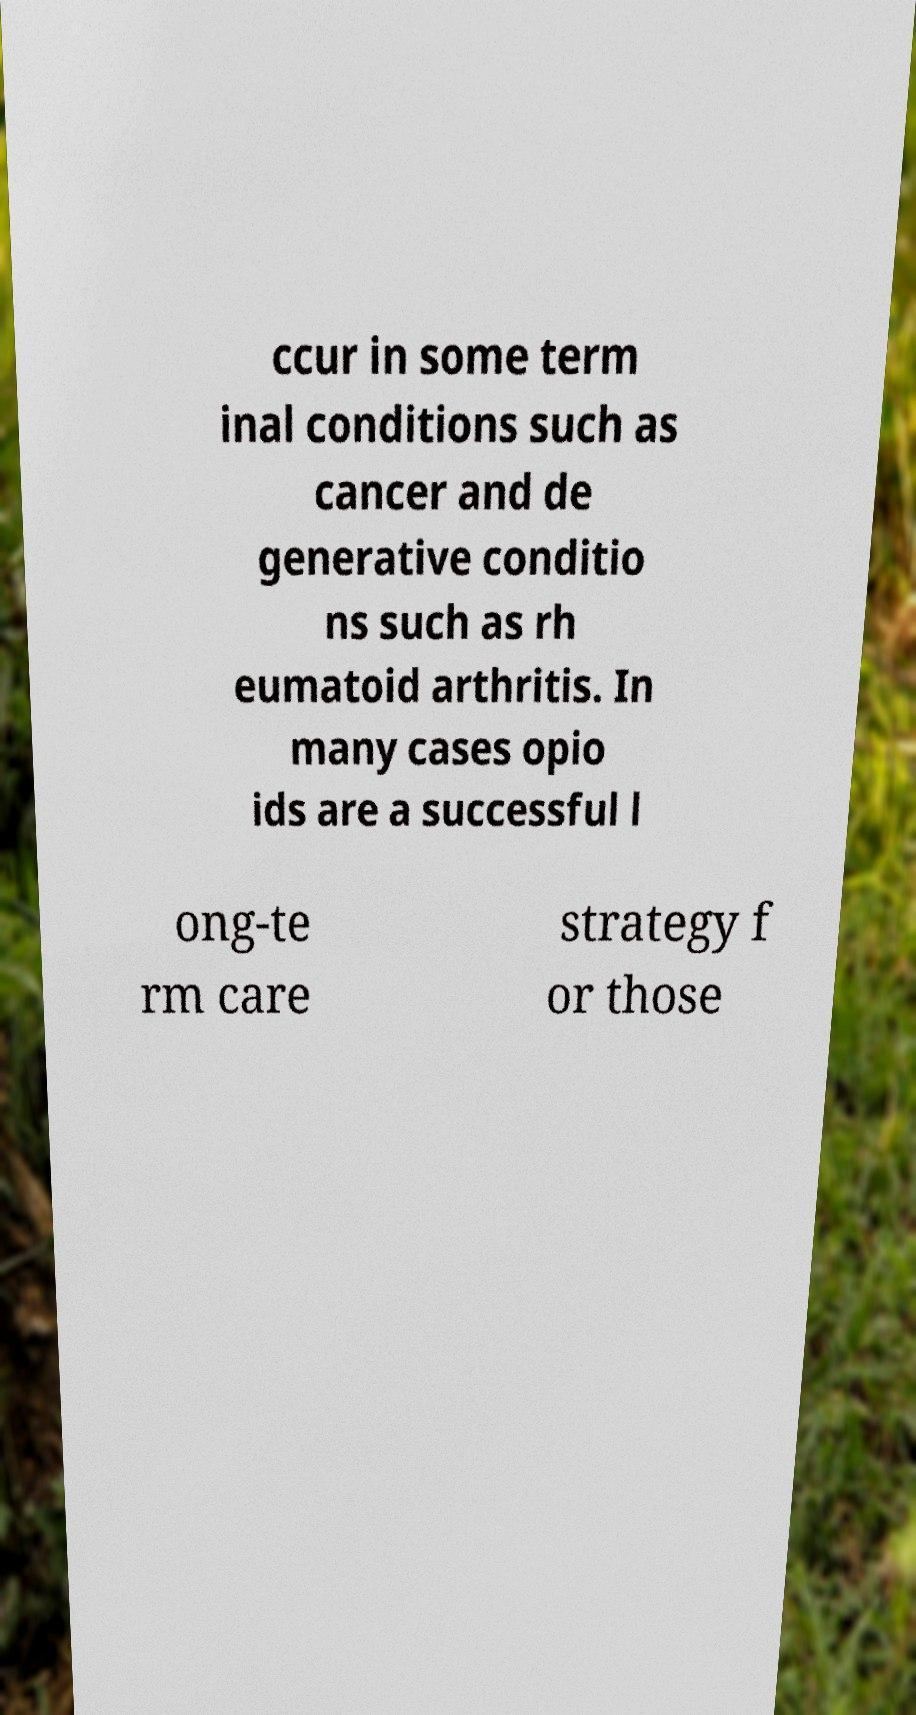Please read and relay the text visible in this image. What does it say? ccur in some term inal conditions such as cancer and de generative conditio ns such as rh eumatoid arthritis. In many cases opio ids are a successful l ong-te rm care strategy f or those 